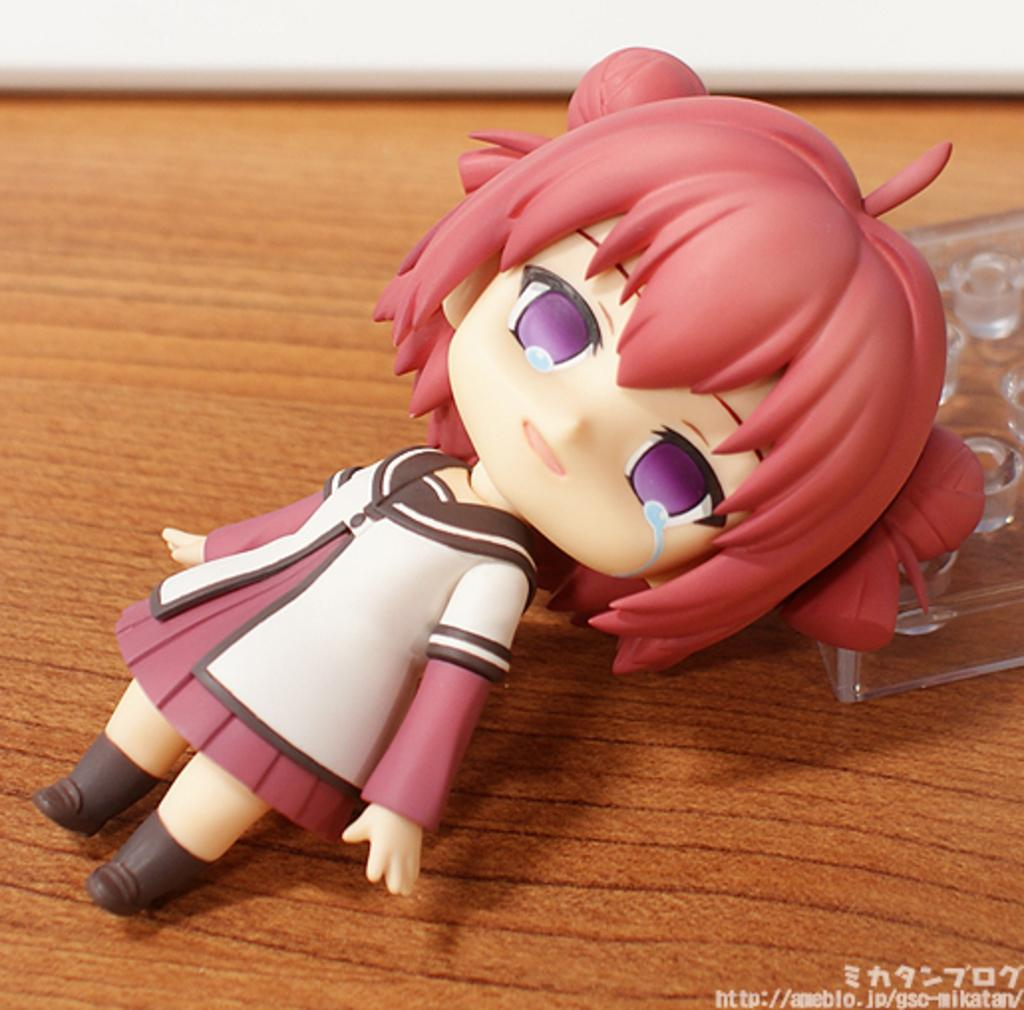What is the main subject in the image? There is a doll in the image. What else can be seen on the right side of the image? There is a plastic thing on the right side of the image. Is there any additional information about the image itself? Yes, there is a watermark on the bottom right side of the image. What type of rings can be seen in the air in the image? There are no rings or air visible in the image; it only features a doll and a plastic thing. 